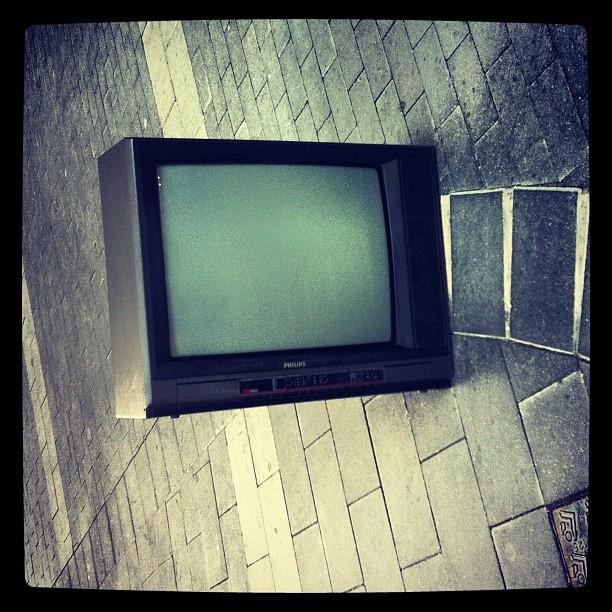Is this device operating right now?
Short answer required. No. Is the TV on?
Be succinct. No. Is the TV right side up?
Give a very brief answer. No. Is this a TV?
Answer briefly. Yes. 